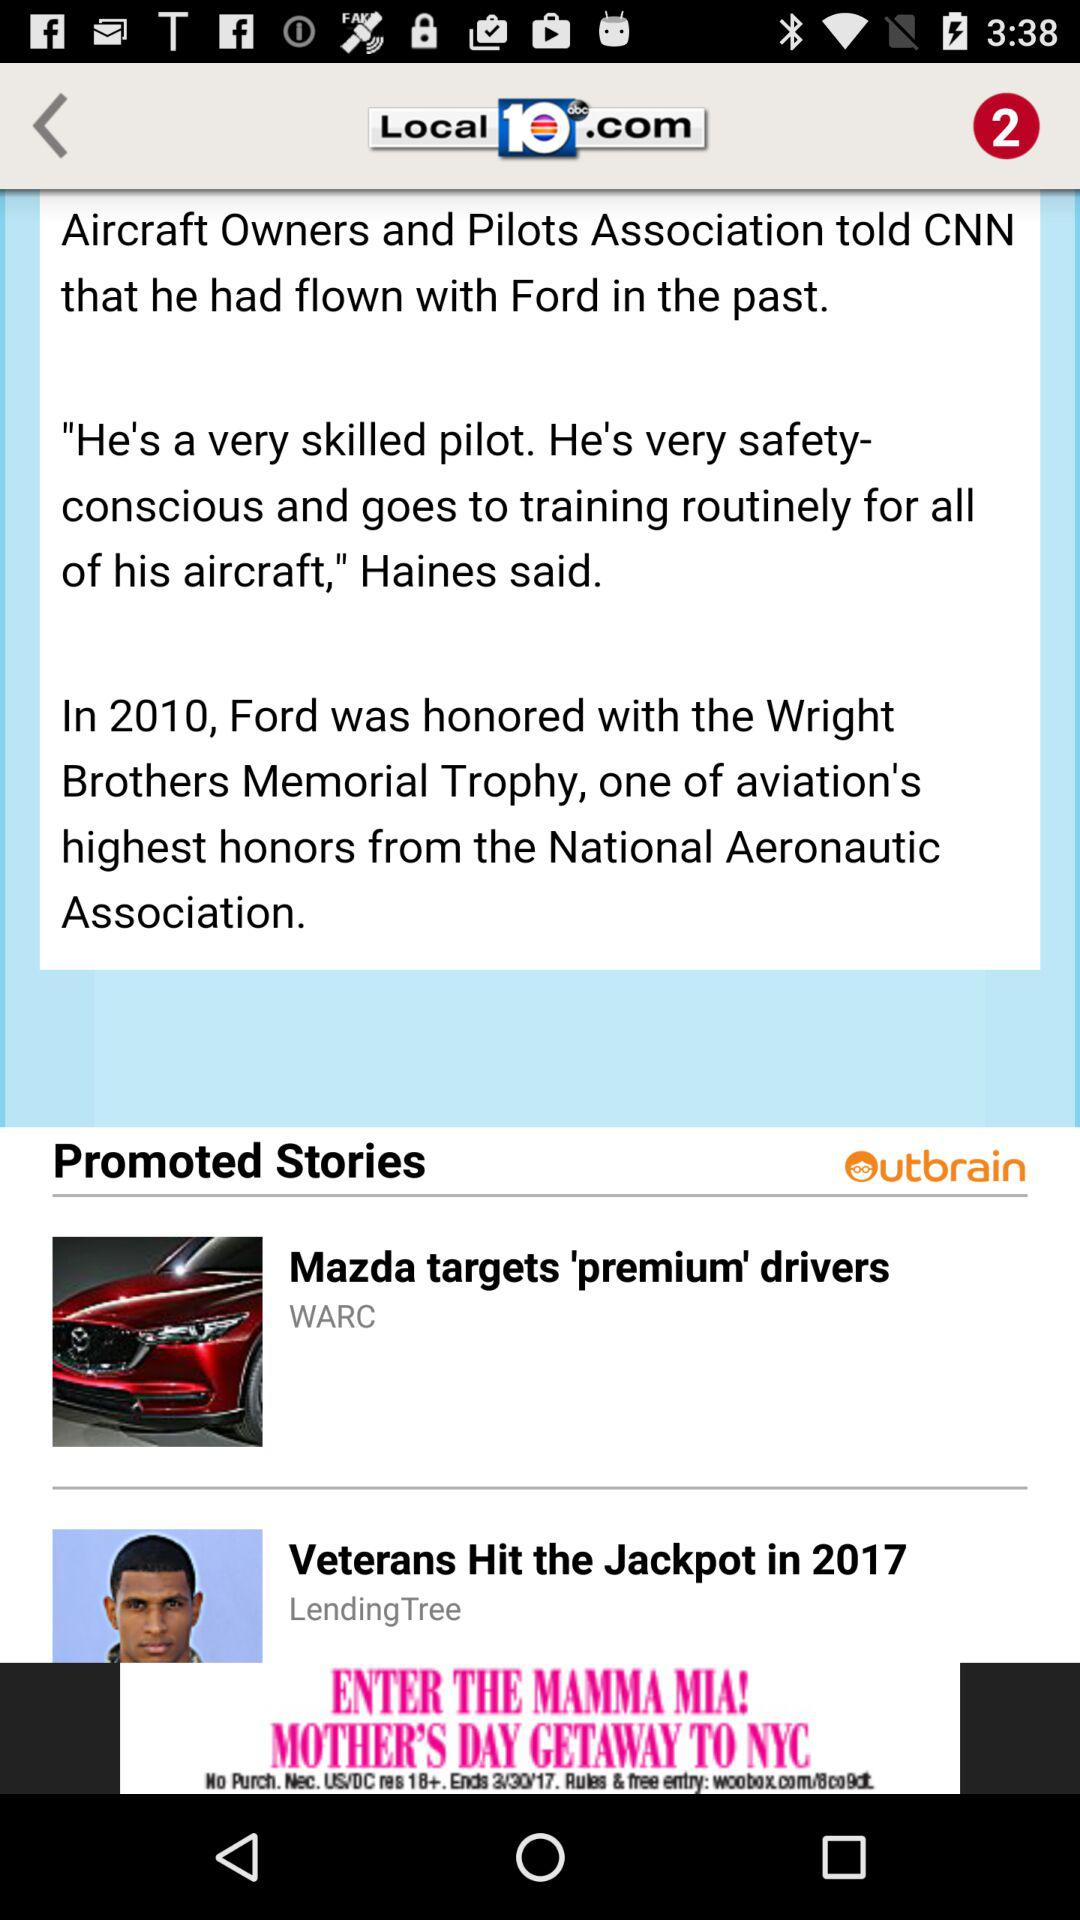What is the channel name? The channel name is "Local10abc.com". 